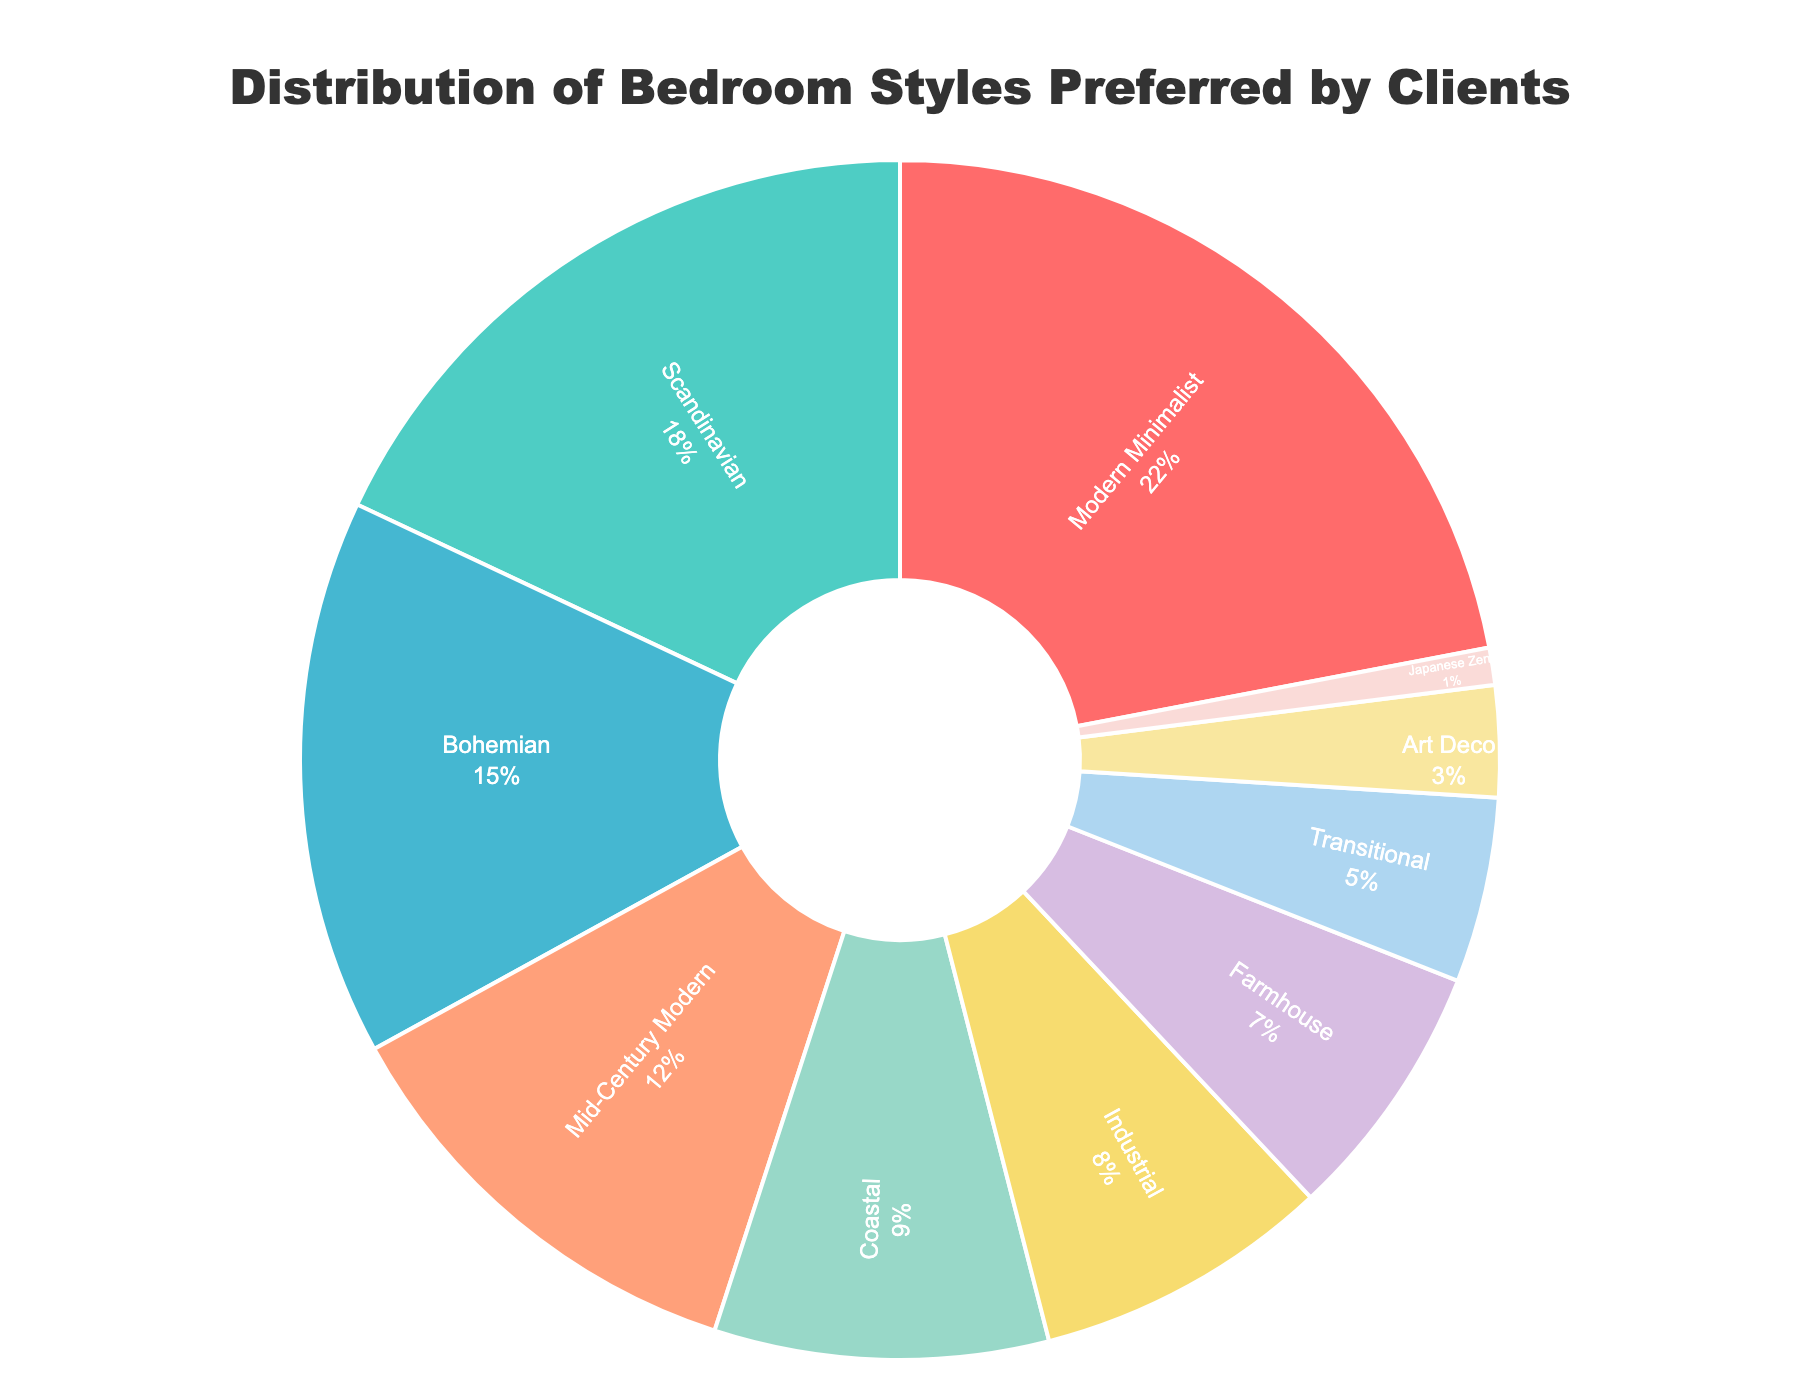What's the most preferred bedroom style? By referring to the figure, the segment representing the "Modern Minimalist" style is the largest, comprising 22% of the chart, indicating that it is the most preferred bedroom style among clients.
Answer: Modern Minimalist Which bedroom styles combined make up over 40% of the preferences? The top two styles are "Modern Minimalist" at 22% and "Scandinavian" at 18%. Summing them up: 22% + 18% = 40%.
Answer: Modern Minimalist and Scandinavian Which bedroom style is preferred by fewer clients: Industrial or Coastal? Referring to the figure, "Industrial" is 8% while "Coastal" is 9%.
Answer: Industrial How much more popular is the Modern Minimalist style compared to the Farmhouse style? The Modern Minimalist style preference is 22%, and the Farmhouse style is 7%. The difference is 22% - 7% = 15%.
Answer: 15% Among the styles with less than 10% popularity each, which one is the least preferred? Among the styles with less than 10% popularity: Coastal (9%), Industrial (8%), Farmhouse (7%), Transitional (5%), Art Deco (3%), and Japanese Zen (1%). The least preferred is the "Japanese Zen" style at 1%.
Answer: Japanese Zen What is the sum percentage of Mid-Century Modern and Bohemian styles? By adding the percentages of Mid-Century Modern (12%) and Bohemian (15%): 12% + 15% = 27%.
Answer: 27% Which style has a larger preference percentage: Art Deco or Transitional? Comparing Art Deco (3%) and Transitional (5%), the Transitional style has a larger preference percentage.
Answer: Transitional How many styles have a preference percentage lower than 5%? Identifying the styles with percentages lower than 5%: Art Deco (3%) and Japanese Zen (1%).
Answer: 2 What's the difference in preference between Scandinavian and Mid-Century Modern styles? Calculating the difference: Scandinavian (18%) - Mid-Century Modern (12%) = 6%.
Answer: 6% What is the combined popularity percentage of all styles except the top two preferred styles? The top two preferred styles are Modern Minimalist (22%) and Scandinavian (18%), combined they make 40%. Subtracting this from 100%: 100% - 40% = 60%.
Answer: 60% 